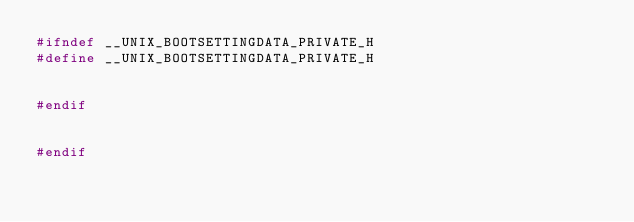<code> <loc_0><loc_0><loc_500><loc_500><_C++_>#ifndef __UNIX_BOOTSETTINGDATA_PRIVATE_H
#define __UNIX_BOOTSETTINGDATA_PRIVATE_H


#endif


#endif
</code> 